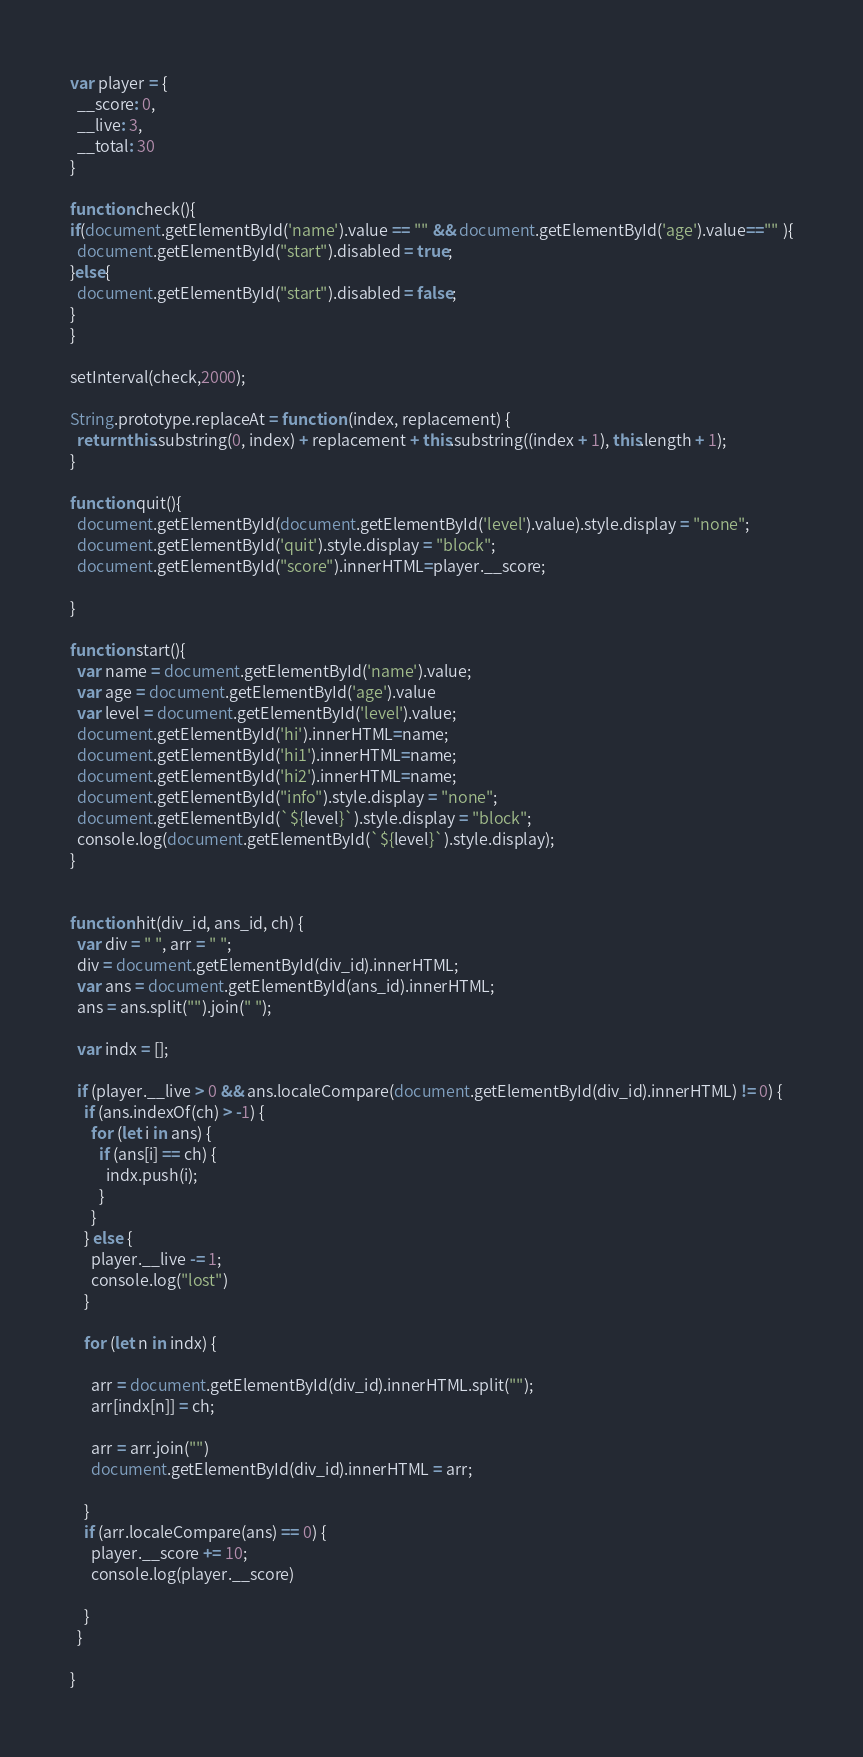<code> <loc_0><loc_0><loc_500><loc_500><_JavaScript_>var player = {
  __score: 0,
  __live: 3,
  __total: 30
}

function check(){
if(document.getElementById('name').value == "" && document.getElementById('age').value=="" ){
  document.getElementById("start").disabled = true;
}else{
  document.getElementById("start").disabled = false;
}
}

setInterval(check,2000);

String.prototype.replaceAt = function (index, replacement) {
  return this.substring(0, index) + replacement + this.substring((index + 1), this.length + 1);
}

function quit(){
  document.getElementById(document.getElementById('level').value).style.display = "none";
  document.getElementById('quit').style.display = "block";
  document.getElementById("score").innerHTML=player.__score;

}

function start(){
  var name = document.getElementById('name').value;
  var age = document.getElementById('age').value
  var level = document.getElementById('level').value;
  document.getElementById('hi').innerHTML=name;
  document.getElementById('hi1').innerHTML=name;
  document.getElementById('hi2').innerHTML=name;
  document.getElementById("info").style.display = "none";
  document.getElementById(`${level}`).style.display = "block";
  console.log(document.getElementById(`${level}`).style.display);
}


function hit(div_id, ans_id, ch) {
  var div = " ", arr = " ";
  div = document.getElementById(div_id).innerHTML;
  var ans = document.getElementById(ans_id).innerHTML;
  ans = ans.split("").join(" ");

  var indx = [];

  if (player.__live > 0 && ans.localeCompare(document.getElementById(div_id).innerHTML) != 0) {
    if (ans.indexOf(ch) > -1) {
      for (let i in ans) {
        if (ans[i] == ch) {
          indx.push(i);
        }
      }
    } else {
      player.__live -= 1;
      console.log("lost")
    }

    for (let n in indx) {

      arr = document.getElementById(div_id).innerHTML.split("");
      arr[indx[n]] = ch;

      arr = arr.join("")
      document.getElementById(div_id).innerHTML = arr;

    }
    if (arr.localeCompare(ans) == 0) {
      player.__score += 10;
      console.log(player.__score)

    }
  }

}
</code> 